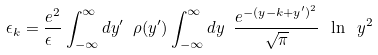<formula> <loc_0><loc_0><loc_500><loc_500>\epsilon _ { k } = \frac { e ^ { 2 } } { \epsilon \ } \int ^ { \infty } _ { - \infty } d y ^ { \prime } \ \rho ( y ^ { \prime } ) \int ^ { \infty } _ { - \infty } d y \ \frac { e ^ { - ( y - k + y ^ { \prime } ) ^ { 2 } } } { \sqrt { \pi } } \ \ln \ y ^ { 2 } \</formula> 